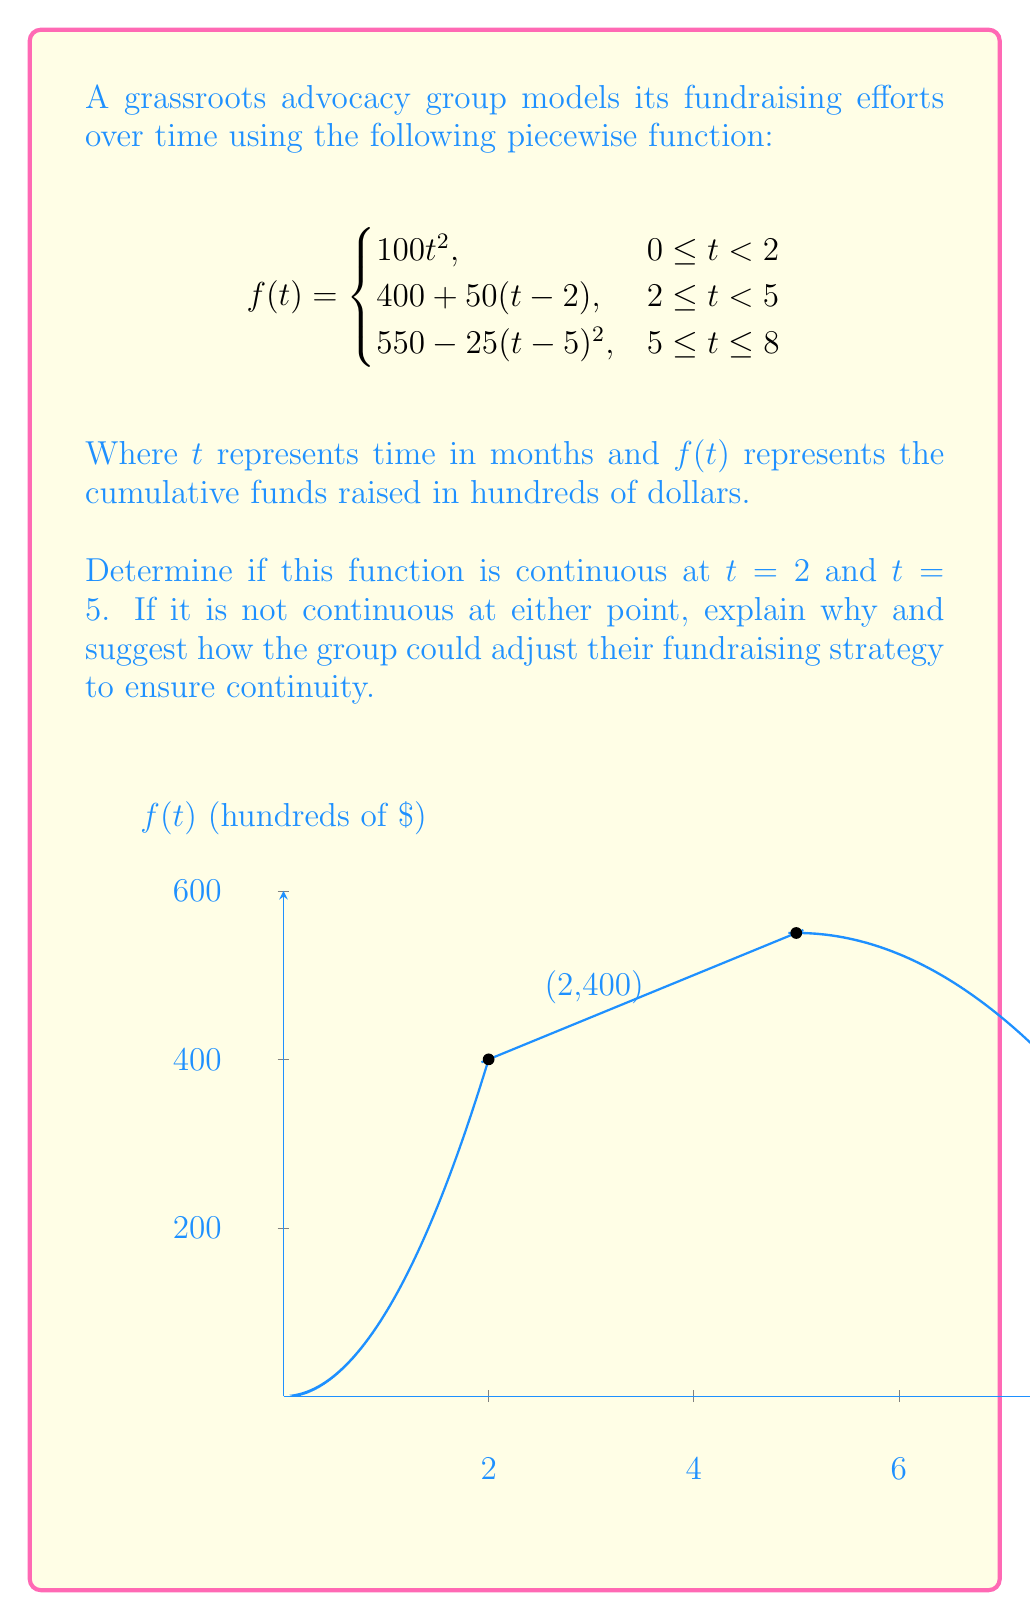Teach me how to tackle this problem. To determine if the function is continuous at $t = 2$ and $t = 5$, we need to check three conditions for each point:
1. The function is defined at the point
2. The limit of the function as we approach the point from both sides exists
3. The limit equals the function value at that point

For $t = 2$:
1. $f(2)$ is defined: $f(2) = 400$ (using the second piece of the function)
2. Left-hand limit: 
   $\lim_{t \to 2^-} 100t^2 = 100(2)^2 = 400$
   Right-hand limit: 
   $\lim_{t \to 2^+} (400 + 50(t-2)) = 400 + 50(0) = 400$
3. Both limits equal $f(2) = 400$

Therefore, the function is continuous at $t = 2$.

For $t = 5$:
1. $f(5)$ is defined: $f(5) = 550$ (using the third piece of the function)
2. Left-hand limit:
   $\lim_{t \to 5^-} (400 + 50(t-2)) = 400 + 50(3) = 550$
   Right-hand limit:
   $\lim_{t \to 5^+} (550 - 25(t-5)^2) = 550 - 25(0)^2 = 550$
3. Both limits equal $f(5) = 550$

Therefore, the function is also continuous at $t = 5$.

The function is continuous at both points, which means the advocacy group's fundraising efforts transition smoothly between different phases. This continuity suggests that their strategy is well-planned and executed, maintaining consistent growth in funds raised over time.
Answer: The function is continuous at both $t = 2$ and $t = 5$. 